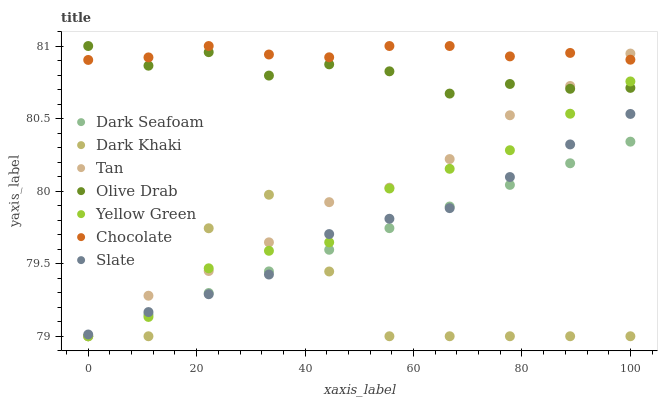Does Dark Khaki have the minimum area under the curve?
Answer yes or no. Yes. Does Chocolate have the maximum area under the curve?
Answer yes or no. Yes. Does Slate have the minimum area under the curve?
Answer yes or no. No. Does Slate have the maximum area under the curve?
Answer yes or no. No. Is Dark Seafoam the smoothest?
Answer yes or no. Yes. Is Dark Khaki the roughest?
Answer yes or no. Yes. Is Slate the smoothest?
Answer yes or no. No. Is Slate the roughest?
Answer yes or no. No. Does Yellow Green have the lowest value?
Answer yes or no. Yes. Does Slate have the lowest value?
Answer yes or no. No. Does Olive Drab have the highest value?
Answer yes or no. Yes. Does Slate have the highest value?
Answer yes or no. No. Is Dark Khaki less than Olive Drab?
Answer yes or no. Yes. Is Chocolate greater than Dark Seafoam?
Answer yes or no. Yes. Does Chocolate intersect Olive Drab?
Answer yes or no. Yes. Is Chocolate less than Olive Drab?
Answer yes or no. No. Is Chocolate greater than Olive Drab?
Answer yes or no. No. Does Dark Khaki intersect Olive Drab?
Answer yes or no. No. 